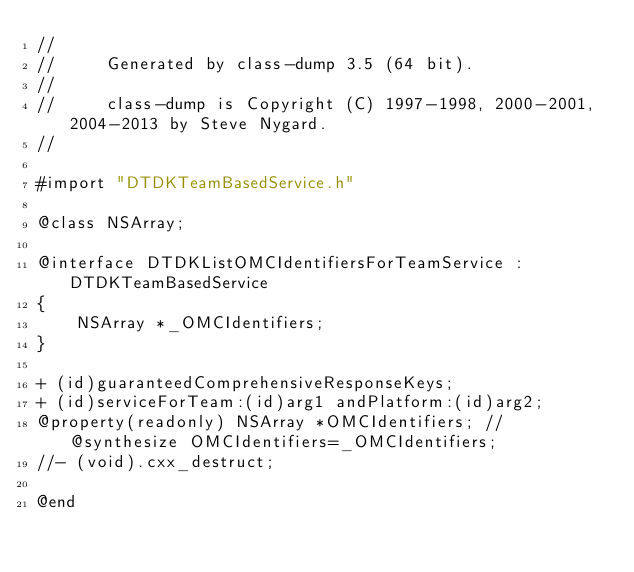Convert code to text. <code><loc_0><loc_0><loc_500><loc_500><_C_>//
//     Generated by class-dump 3.5 (64 bit).
//
//     class-dump is Copyright (C) 1997-1998, 2000-2001, 2004-2013 by Steve Nygard.
//

#import "DTDKTeamBasedService.h"

@class NSArray;

@interface DTDKListOMCIdentifiersForTeamService : DTDKTeamBasedService
{
    NSArray *_OMCIdentifiers;
}

+ (id)guaranteedComprehensiveResponseKeys;
+ (id)serviceForTeam:(id)arg1 andPlatform:(id)arg2;
@property(readonly) NSArray *OMCIdentifiers; // @synthesize OMCIdentifiers=_OMCIdentifiers;
//- (void).cxx_destruct;

@end

</code> 